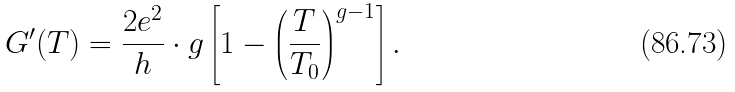Convert formula to latex. <formula><loc_0><loc_0><loc_500><loc_500>G ^ { \prime } ( T ) = \frac { 2 e ^ { 2 } } { h } \cdot g \left [ 1 - \left ( \frac { T } { T _ { 0 } } \right ) ^ { g - 1 } \right ] .</formula> 